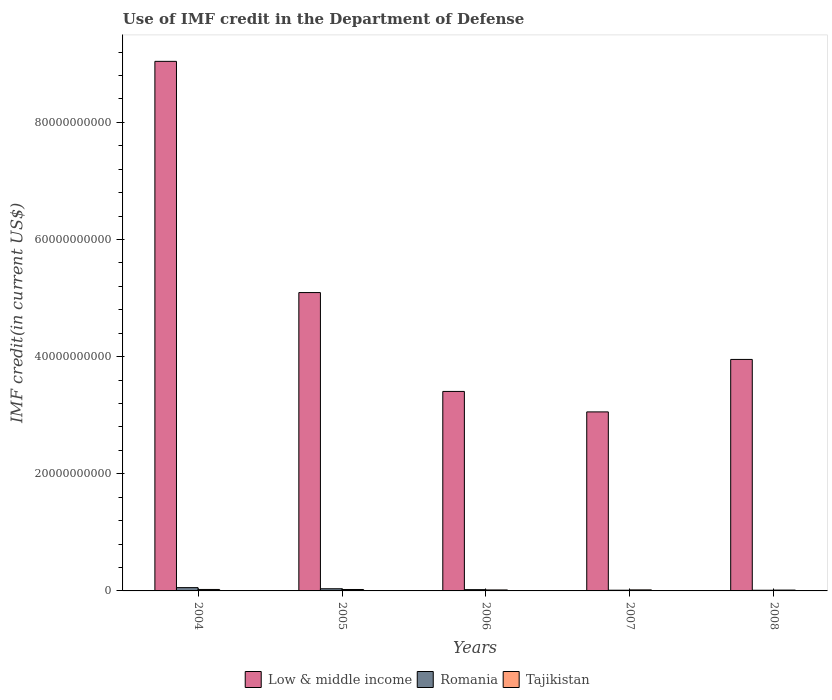Are the number of bars per tick equal to the number of legend labels?
Ensure brevity in your answer.  Yes. How many bars are there on the 2nd tick from the left?
Provide a succinct answer. 3. How many bars are there on the 2nd tick from the right?
Provide a short and direct response. 3. What is the label of the 5th group of bars from the left?
Make the answer very short. 2008. In how many cases, is the number of bars for a given year not equal to the number of legend labels?
Provide a short and direct response. 0. What is the IMF credit in the Department of Defense in Tajikistan in 2006?
Offer a very short reply. 1.68e+08. Across all years, what is the maximum IMF credit in the Department of Defense in Romania?
Your answer should be compact. 5.61e+08. Across all years, what is the minimum IMF credit in the Department of Defense in Low & middle income?
Make the answer very short. 3.06e+1. What is the total IMF credit in the Department of Defense in Romania in the graph?
Give a very brief answer. 1.39e+09. What is the difference between the IMF credit in the Department of Defense in Tajikistan in 2004 and that in 2006?
Keep it short and to the point. 8.20e+07. What is the difference between the IMF credit in the Department of Defense in Low & middle income in 2007 and the IMF credit in the Department of Defense in Tajikistan in 2004?
Your response must be concise. 3.03e+1. What is the average IMF credit in the Department of Defense in Low & middle income per year?
Offer a terse response. 4.91e+1. In the year 2006, what is the difference between the IMF credit in the Department of Defense in Tajikistan and IMF credit in the Department of Defense in Low & middle income?
Your response must be concise. -3.39e+1. What is the ratio of the IMF credit in the Department of Defense in Romania in 2005 to that in 2008?
Make the answer very short. 3.16. What is the difference between the highest and the second highest IMF credit in the Department of Defense in Romania?
Make the answer very short. 1.92e+08. What is the difference between the highest and the lowest IMF credit in the Department of Defense in Tajikistan?
Your answer should be compact. 1.08e+08. Is the sum of the IMF credit in the Department of Defense in Low & middle income in 2004 and 2007 greater than the maximum IMF credit in the Department of Defense in Romania across all years?
Keep it short and to the point. Yes. What does the 3rd bar from the left in 2008 represents?
Ensure brevity in your answer.  Tajikistan. What does the 3rd bar from the right in 2004 represents?
Provide a short and direct response. Low & middle income. Are all the bars in the graph horizontal?
Make the answer very short. No. How many years are there in the graph?
Provide a succinct answer. 5. Are the values on the major ticks of Y-axis written in scientific E-notation?
Ensure brevity in your answer.  No. Where does the legend appear in the graph?
Provide a short and direct response. Bottom center. What is the title of the graph?
Give a very brief answer. Use of IMF credit in the Department of Defense. Does "South Sudan" appear as one of the legend labels in the graph?
Make the answer very short. No. What is the label or title of the Y-axis?
Offer a very short reply. IMF credit(in current US$). What is the IMF credit(in current US$) in Low & middle income in 2004?
Offer a very short reply. 9.04e+1. What is the IMF credit(in current US$) in Romania in 2004?
Offer a very short reply. 5.61e+08. What is the IMF credit(in current US$) of Tajikistan in 2004?
Offer a terse response. 2.50e+08. What is the IMF credit(in current US$) of Low & middle income in 2005?
Give a very brief answer. 5.09e+1. What is the IMF credit(in current US$) of Romania in 2005?
Your answer should be compact. 3.69e+08. What is the IMF credit(in current US$) in Tajikistan in 2005?
Make the answer very short. 2.44e+08. What is the IMF credit(in current US$) in Low & middle income in 2006?
Your answer should be very brief. 3.41e+1. What is the IMF credit(in current US$) in Romania in 2006?
Your answer should be very brief. 2.18e+08. What is the IMF credit(in current US$) in Tajikistan in 2006?
Your answer should be very brief. 1.68e+08. What is the IMF credit(in current US$) in Low & middle income in 2007?
Give a very brief answer. 3.06e+1. What is the IMF credit(in current US$) of Romania in 2007?
Your response must be concise. 1.20e+08. What is the IMF credit(in current US$) in Tajikistan in 2007?
Offer a terse response. 1.76e+08. What is the IMF credit(in current US$) in Low & middle income in 2008?
Ensure brevity in your answer.  3.95e+1. What is the IMF credit(in current US$) of Romania in 2008?
Keep it short and to the point. 1.17e+08. What is the IMF credit(in current US$) in Tajikistan in 2008?
Provide a short and direct response. 1.42e+08. Across all years, what is the maximum IMF credit(in current US$) of Low & middle income?
Make the answer very short. 9.04e+1. Across all years, what is the maximum IMF credit(in current US$) in Romania?
Offer a very short reply. 5.61e+08. Across all years, what is the maximum IMF credit(in current US$) in Tajikistan?
Give a very brief answer. 2.50e+08. Across all years, what is the minimum IMF credit(in current US$) in Low & middle income?
Ensure brevity in your answer.  3.06e+1. Across all years, what is the minimum IMF credit(in current US$) in Romania?
Your response must be concise. 1.17e+08. Across all years, what is the minimum IMF credit(in current US$) in Tajikistan?
Keep it short and to the point. 1.42e+08. What is the total IMF credit(in current US$) in Low & middle income in the graph?
Provide a short and direct response. 2.46e+11. What is the total IMF credit(in current US$) in Romania in the graph?
Offer a terse response. 1.39e+09. What is the total IMF credit(in current US$) of Tajikistan in the graph?
Ensure brevity in your answer.  9.80e+08. What is the difference between the IMF credit(in current US$) in Low & middle income in 2004 and that in 2005?
Make the answer very short. 3.95e+1. What is the difference between the IMF credit(in current US$) in Romania in 2004 and that in 2005?
Your answer should be very brief. 1.92e+08. What is the difference between the IMF credit(in current US$) in Tajikistan in 2004 and that in 2005?
Offer a very short reply. 5.30e+06. What is the difference between the IMF credit(in current US$) of Low & middle income in 2004 and that in 2006?
Provide a succinct answer. 5.64e+1. What is the difference between the IMF credit(in current US$) of Romania in 2004 and that in 2006?
Your response must be concise. 3.43e+08. What is the difference between the IMF credit(in current US$) in Tajikistan in 2004 and that in 2006?
Your answer should be very brief. 8.20e+07. What is the difference between the IMF credit(in current US$) of Low & middle income in 2004 and that in 2007?
Make the answer very short. 5.99e+1. What is the difference between the IMF credit(in current US$) in Romania in 2004 and that in 2007?
Offer a terse response. 4.41e+08. What is the difference between the IMF credit(in current US$) of Tajikistan in 2004 and that in 2007?
Keep it short and to the point. 7.35e+07. What is the difference between the IMF credit(in current US$) of Low & middle income in 2004 and that in 2008?
Your response must be concise. 5.09e+1. What is the difference between the IMF credit(in current US$) in Romania in 2004 and that in 2008?
Your answer should be very brief. 4.44e+08. What is the difference between the IMF credit(in current US$) of Tajikistan in 2004 and that in 2008?
Your response must be concise. 1.08e+08. What is the difference between the IMF credit(in current US$) in Low & middle income in 2005 and that in 2006?
Your response must be concise. 1.69e+1. What is the difference between the IMF credit(in current US$) of Romania in 2005 and that in 2006?
Your answer should be compact. 1.52e+08. What is the difference between the IMF credit(in current US$) of Tajikistan in 2005 and that in 2006?
Provide a short and direct response. 7.67e+07. What is the difference between the IMF credit(in current US$) of Low & middle income in 2005 and that in 2007?
Offer a very short reply. 2.04e+1. What is the difference between the IMF credit(in current US$) in Romania in 2005 and that in 2007?
Give a very brief answer. 2.49e+08. What is the difference between the IMF credit(in current US$) in Tajikistan in 2005 and that in 2007?
Provide a short and direct response. 6.82e+07. What is the difference between the IMF credit(in current US$) in Low & middle income in 2005 and that in 2008?
Provide a succinct answer. 1.14e+1. What is the difference between the IMF credit(in current US$) of Romania in 2005 and that in 2008?
Give a very brief answer. 2.52e+08. What is the difference between the IMF credit(in current US$) of Tajikistan in 2005 and that in 2008?
Ensure brevity in your answer.  1.03e+08. What is the difference between the IMF credit(in current US$) in Low & middle income in 2006 and that in 2007?
Ensure brevity in your answer.  3.49e+09. What is the difference between the IMF credit(in current US$) of Romania in 2006 and that in 2007?
Provide a succinct answer. 9.79e+07. What is the difference between the IMF credit(in current US$) in Tajikistan in 2006 and that in 2007?
Offer a terse response. -8.46e+06. What is the difference between the IMF credit(in current US$) in Low & middle income in 2006 and that in 2008?
Offer a very short reply. -5.47e+09. What is the difference between the IMF credit(in current US$) of Romania in 2006 and that in 2008?
Your response must be concise. 1.01e+08. What is the difference between the IMF credit(in current US$) in Tajikistan in 2006 and that in 2008?
Provide a succinct answer. 2.62e+07. What is the difference between the IMF credit(in current US$) in Low & middle income in 2007 and that in 2008?
Make the answer very short. -8.96e+09. What is the difference between the IMF credit(in current US$) of Romania in 2007 and that in 2008?
Offer a very short reply. 3.04e+06. What is the difference between the IMF credit(in current US$) in Tajikistan in 2007 and that in 2008?
Your answer should be very brief. 3.46e+07. What is the difference between the IMF credit(in current US$) in Low & middle income in 2004 and the IMF credit(in current US$) in Romania in 2005?
Your answer should be compact. 9.00e+1. What is the difference between the IMF credit(in current US$) of Low & middle income in 2004 and the IMF credit(in current US$) of Tajikistan in 2005?
Offer a very short reply. 9.02e+1. What is the difference between the IMF credit(in current US$) in Romania in 2004 and the IMF credit(in current US$) in Tajikistan in 2005?
Ensure brevity in your answer.  3.17e+08. What is the difference between the IMF credit(in current US$) of Low & middle income in 2004 and the IMF credit(in current US$) of Romania in 2006?
Your response must be concise. 9.02e+1. What is the difference between the IMF credit(in current US$) of Low & middle income in 2004 and the IMF credit(in current US$) of Tajikistan in 2006?
Provide a succinct answer. 9.03e+1. What is the difference between the IMF credit(in current US$) in Romania in 2004 and the IMF credit(in current US$) in Tajikistan in 2006?
Keep it short and to the point. 3.93e+08. What is the difference between the IMF credit(in current US$) of Low & middle income in 2004 and the IMF credit(in current US$) of Romania in 2007?
Offer a very short reply. 9.03e+1. What is the difference between the IMF credit(in current US$) of Low & middle income in 2004 and the IMF credit(in current US$) of Tajikistan in 2007?
Keep it short and to the point. 9.02e+1. What is the difference between the IMF credit(in current US$) of Romania in 2004 and the IMF credit(in current US$) of Tajikistan in 2007?
Give a very brief answer. 3.85e+08. What is the difference between the IMF credit(in current US$) of Low & middle income in 2004 and the IMF credit(in current US$) of Romania in 2008?
Keep it short and to the point. 9.03e+1. What is the difference between the IMF credit(in current US$) of Low & middle income in 2004 and the IMF credit(in current US$) of Tajikistan in 2008?
Keep it short and to the point. 9.03e+1. What is the difference between the IMF credit(in current US$) in Romania in 2004 and the IMF credit(in current US$) in Tajikistan in 2008?
Provide a succinct answer. 4.20e+08. What is the difference between the IMF credit(in current US$) of Low & middle income in 2005 and the IMF credit(in current US$) of Romania in 2006?
Make the answer very short. 5.07e+1. What is the difference between the IMF credit(in current US$) in Low & middle income in 2005 and the IMF credit(in current US$) in Tajikistan in 2006?
Make the answer very short. 5.08e+1. What is the difference between the IMF credit(in current US$) of Romania in 2005 and the IMF credit(in current US$) of Tajikistan in 2006?
Your answer should be very brief. 2.02e+08. What is the difference between the IMF credit(in current US$) in Low & middle income in 2005 and the IMF credit(in current US$) in Romania in 2007?
Give a very brief answer. 5.08e+1. What is the difference between the IMF credit(in current US$) of Low & middle income in 2005 and the IMF credit(in current US$) of Tajikistan in 2007?
Your response must be concise. 5.08e+1. What is the difference between the IMF credit(in current US$) in Romania in 2005 and the IMF credit(in current US$) in Tajikistan in 2007?
Ensure brevity in your answer.  1.93e+08. What is the difference between the IMF credit(in current US$) in Low & middle income in 2005 and the IMF credit(in current US$) in Romania in 2008?
Keep it short and to the point. 5.08e+1. What is the difference between the IMF credit(in current US$) of Low & middle income in 2005 and the IMF credit(in current US$) of Tajikistan in 2008?
Provide a short and direct response. 5.08e+1. What is the difference between the IMF credit(in current US$) in Romania in 2005 and the IMF credit(in current US$) in Tajikistan in 2008?
Ensure brevity in your answer.  2.28e+08. What is the difference between the IMF credit(in current US$) in Low & middle income in 2006 and the IMF credit(in current US$) in Romania in 2007?
Provide a short and direct response. 3.39e+1. What is the difference between the IMF credit(in current US$) of Low & middle income in 2006 and the IMF credit(in current US$) of Tajikistan in 2007?
Your response must be concise. 3.39e+1. What is the difference between the IMF credit(in current US$) in Romania in 2006 and the IMF credit(in current US$) in Tajikistan in 2007?
Offer a very short reply. 4.17e+07. What is the difference between the IMF credit(in current US$) of Low & middle income in 2006 and the IMF credit(in current US$) of Romania in 2008?
Your response must be concise. 3.39e+1. What is the difference between the IMF credit(in current US$) in Low & middle income in 2006 and the IMF credit(in current US$) in Tajikistan in 2008?
Ensure brevity in your answer.  3.39e+1. What is the difference between the IMF credit(in current US$) in Romania in 2006 and the IMF credit(in current US$) in Tajikistan in 2008?
Your response must be concise. 7.64e+07. What is the difference between the IMF credit(in current US$) in Low & middle income in 2007 and the IMF credit(in current US$) in Romania in 2008?
Offer a very short reply. 3.04e+1. What is the difference between the IMF credit(in current US$) of Low & middle income in 2007 and the IMF credit(in current US$) of Tajikistan in 2008?
Provide a succinct answer. 3.04e+1. What is the difference between the IMF credit(in current US$) of Romania in 2007 and the IMF credit(in current US$) of Tajikistan in 2008?
Your response must be concise. -2.15e+07. What is the average IMF credit(in current US$) of Low & middle income per year?
Provide a succinct answer. 4.91e+1. What is the average IMF credit(in current US$) of Romania per year?
Give a very brief answer. 2.77e+08. What is the average IMF credit(in current US$) of Tajikistan per year?
Your response must be concise. 1.96e+08. In the year 2004, what is the difference between the IMF credit(in current US$) of Low & middle income and IMF credit(in current US$) of Romania?
Give a very brief answer. 8.99e+1. In the year 2004, what is the difference between the IMF credit(in current US$) in Low & middle income and IMF credit(in current US$) in Tajikistan?
Provide a succinct answer. 9.02e+1. In the year 2004, what is the difference between the IMF credit(in current US$) of Romania and IMF credit(in current US$) of Tajikistan?
Offer a terse response. 3.11e+08. In the year 2005, what is the difference between the IMF credit(in current US$) in Low & middle income and IMF credit(in current US$) in Romania?
Offer a very short reply. 5.06e+1. In the year 2005, what is the difference between the IMF credit(in current US$) of Low & middle income and IMF credit(in current US$) of Tajikistan?
Offer a very short reply. 5.07e+1. In the year 2005, what is the difference between the IMF credit(in current US$) of Romania and IMF credit(in current US$) of Tajikistan?
Provide a short and direct response. 1.25e+08. In the year 2006, what is the difference between the IMF credit(in current US$) of Low & middle income and IMF credit(in current US$) of Romania?
Offer a terse response. 3.38e+1. In the year 2006, what is the difference between the IMF credit(in current US$) in Low & middle income and IMF credit(in current US$) in Tajikistan?
Offer a terse response. 3.39e+1. In the year 2006, what is the difference between the IMF credit(in current US$) of Romania and IMF credit(in current US$) of Tajikistan?
Your response must be concise. 5.02e+07. In the year 2007, what is the difference between the IMF credit(in current US$) in Low & middle income and IMF credit(in current US$) in Romania?
Provide a short and direct response. 3.04e+1. In the year 2007, what is the difference between the IMF credit(in current US$) in Low & middle income and IMF credit(in current US$) in Tajikistan?
Your answer should be compact. 3.04e+1. In the year 2007, what is the difference between the IMF credit(in current US$) of Romania and IMF credit(in current US$) of Tajikistan?
Make the answer very short. -5.61e+07. In the year 2008, what is the difference between the IMF credit(in current US$) of Low & middle income and IMF credit(in current US$) of Romania?
Make the answer very short. 3.94e+1. In the year 2008, what is the difference between the IMF credit(in current US$) of Low & middle income and IMF credit(in current US$) of Tajikistan?
Your answer should be compact. 3.94e+1. In the year 2008, what is the difference between the IMF credit(in current US$) of Romania and IMF credit(in current US$) of Tajikistan?
Your response must be concise. -2.45e+07. What is the ratio of the IMF credit(in current US$) in Low & middle income in 2004 to that in 2005?
Provide a succinct answer. 1.77. What is the ratio of the IMF credit(in current US$) in Romania in 2004 to that in 2005?
Give a very brief answer. 1.52. What is the ratio of the IMF credit(in current US$) of Tajikistan in 2004 to that in 2005?
Your answer should be very brief. 1.02. What is the ratio of the IMF credit(in current US$) of Low & middle income in 2004 to that in 2006?
Provide a short and direct response. 2.65. What is the ratio of the IMF credit(in current US$) in Romania in 2004 to that in 2006?
Keep it short and to the point. 2.58. What is the ratio of the IMF credit(in current US$) of Tajikistan in 2004 to that in 2006?
Provide a succinct answer. 1.49. What is the ratio of the IMF credit(in current US$) of Low & middle income in 2004 to that in 2007?
Your response must be concise. 2.96. What is the ratio of the IMF credit(in current US$) of Romania in 2004 to that in 2007?
Keep it short and to the point. 4.68. What is the ratio of the IMF credit(in current US$) in Tajikistan in 2004 to that in 2007?
Your answer should be compact. 1.42. What is the ratio of the IMF credit(in current US$) of Low & middle income in 2004 to that in 2008?
Provide a short and direct response. 2.29. What is the ratio of the IMF credit(in current US$) in Romania in 2004 to that in 2008?
Provide a succinct answer. 4.8. What is the ratio of the IMF credit(in current US$) of Tajikistan in 2004 to that in 2008?
Your response must be concise. 1.76. What is the ratio of the IMF credit(in current US$) in Low & middle income in 2005 to that in 2006?
Offer a very short reply. 1.5. What is the ratio of the IMF credit(in current US$) in Romania in 2005 to that in 2006?
Your answer should be very brief. 1.7. What is the ratio of the IMF credit(in current US$) in Tajikistan in 2005 to that in 2006?
Offer a very short reply. 1.46. What is the ratio of the IMF credit(in current US$) of Low & middle income in 2005 to that in 2007?
Offer a terse response. 1.67. What is the ratio of the IMF credit(in current US$) of Romania in 2005 to that in 2007?
Offer a terse response. 3.08. What is the ratio of the IMF credit(in current US$) in Tajikistan in 2005 to that in 2007?
Offer a very short reply. 1.39. What is the ratio of the IMF credit(in current US$) of Low & middle income in 2005 to that in 2008?
Your answer should be compact. 1.29. What is the ratio of the IMF credit(in current US$) in Romania in 2005 to that in 2008?
Offer a terse response. 3.16. What is the ratio of the IMF credit(in current US$) in Tajikistan in 2005 to that in 2008?
Provide a succinct answer. 1.73. What is the ratio of the IMF credit(in current US$) in Low & middle income in 2006 to that in 2007?
Your response must be concise. 1.11. What is the ratio of the IMF credit(in current US$) in Romania in 2006 to that in 2007?
Make the answer very short. 1.82. What is the ratio of the IMF credit(in current US$) of Low & middle income in 2006 to that in 2008?
Offer a very short reply. 0.86. What is the ratio of the IMF credit(in current US$) in Romania in 2006 to that in 2008?
Your response must be concise. 1.86. What is the ratio of the IMF credit(in current US$) of Tajikistan in 2006 to that in 2008?
Keep it short and to the point. 1.19. What is the ratio of the IMF credit(in current US$) of Low & middle income in 2007 to that in 2008?
Ensure brevity in your answer.  0.77. What is the ratio of the IMF credit(in current US$) of Romania in 2007 to that in 2008?
Your answer should be very brief. 1.03. What is the ratio of the IMF credit(in current US$) in Tajikistan in 2007 to that in 2008?
Provide a short and direct response. 1.24. What is the difference between the highest and the second highest IMF credit(in current US$) in Low & middle income?
Keep it short and to the point. 3.95e+1. What is the difference between the highest and the second highest IMF credit(in current US$) in Romania?
Provide a succinct answer. 1.92e+08. What is the difference between the highest and the second highest IMF credit(in current US$) of Tajikistan?
Your answer should be compact. 5.30e+06. What is the difference between the highest and the lowest IMF credit(in current US$) in Low & middle income?
Your answer should be compact. 5.99e+1. What is the difference between the highest and the lowest IMF credit(in current US$) in Romania?
Offer a very short reply. 4.44e+08. What is the difference between the highest and the lowest IMF credit(in current US$) of Tajikistan?
Make the answer very short. 1.08e+08. 